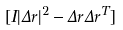<formula> <loc_0><loc_0><loc_500><loc_500>[ I | \Delta r | ^ { 2 } - \Delta r \Delta r ^ { T } ]</formula> 